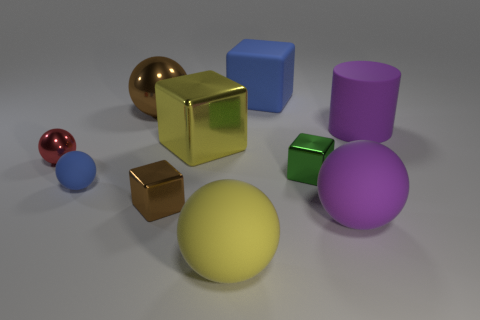Subtract all blue balls. How many balls are left? 4 Subtract 1 cubes. How many cubes are left? 3 Subtract all small blue matte balls. How many balls are left? 4 Subtract all cyan balls. Subtract all brown cylinders. How many balls are left? 5 Subtract all cubes. How many objects are left? 6 Subtract 1 blue blocks. How many objects are left? 9 Subtract all green shiny things. Subtract all blue spheres. How many objects are left? 8 Add 2 large metallic blocks. How many large metallic blocks are left? 3 Add 8 big blocks. How many big blocks exist? 10 